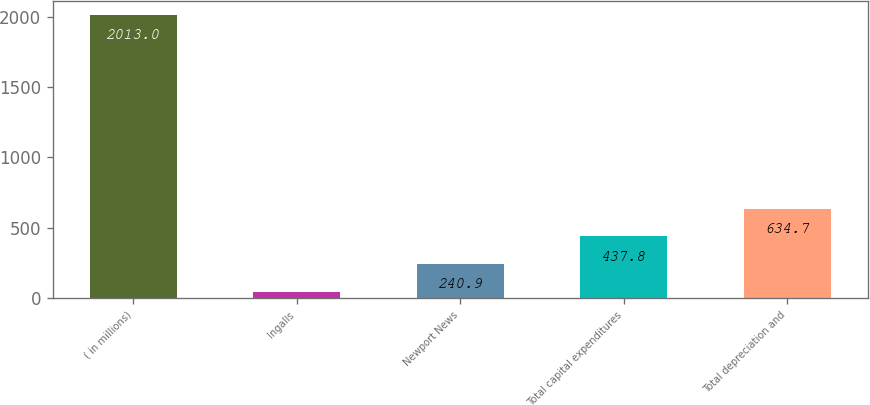<chart> <loc_0><loc_0><loc_500><loc_500><bar_chart><fcel>( in millions)<fcel>Ingalls<fcel>Newport News<fcel>Total capital expenditures<fcel>Total depreciation and<nl><fcel>2013<fcel>44<fcel>240.9<fcel>437.8<fcel>634.7<nl></chart> 